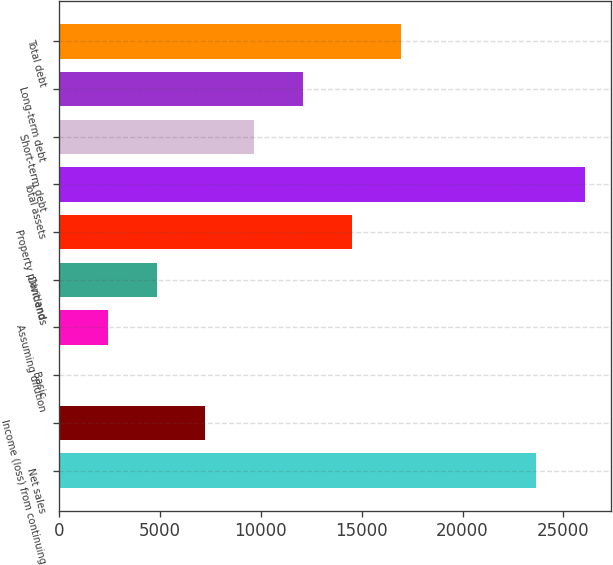<chart> <loc_0><loc_0><loc_500><loc_500><bar_chart><fcel>Net sales<fcel>Income (loss) from continuing<fcel>Basic<fcel>Assuming dilution<fcel>Dividends<fcel>Property plant and<fcel>Total assets<fcel>Short-term debt<fcel>Long-term debt<fcel>Total debt<nl><fcel>23652<fcel>7267.89<fcel>0.12<fcel>2422.71<fcel>4845.3<fcel>14535.7<fcel>26074.6<fcel>9690.48<fcel>12113.1<fcel>16958.2<nl></chart> 